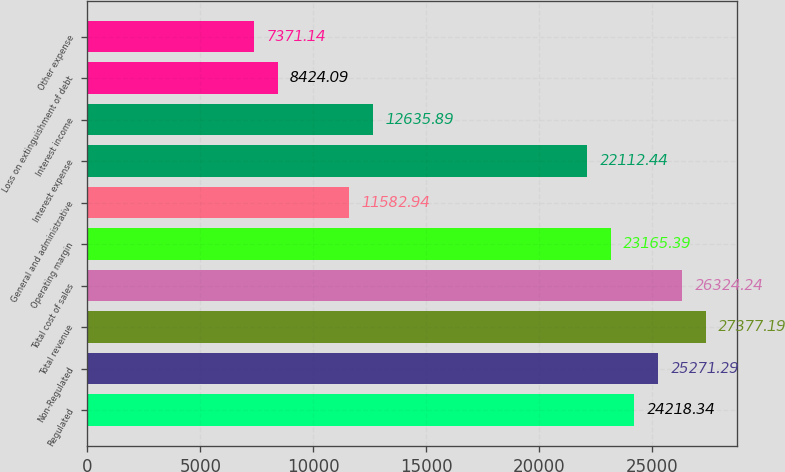Convert chart. <chart><loc_0><loc_0><loc_500><loc_500><bar_chart><fcel>Regulated<fcel>Non-Regulated<fcel>Total revenue<fcel>Total cost of sales<fcel>Operating margin<fcel>General and administrative<fcel>Interest expense<fcel>Interest income<fcel>Loss on extinguishment of debt<fcel>Other expense<nl><fcel>24218.3<fcel>25271.3<fcel>27377.2<fcel>26324.2<fcel>23165.4<fcel>11582.9<fcel>22112.4<fcel>12635.9<fcel>8424.09<fcel>7371.14<nl></chart> 